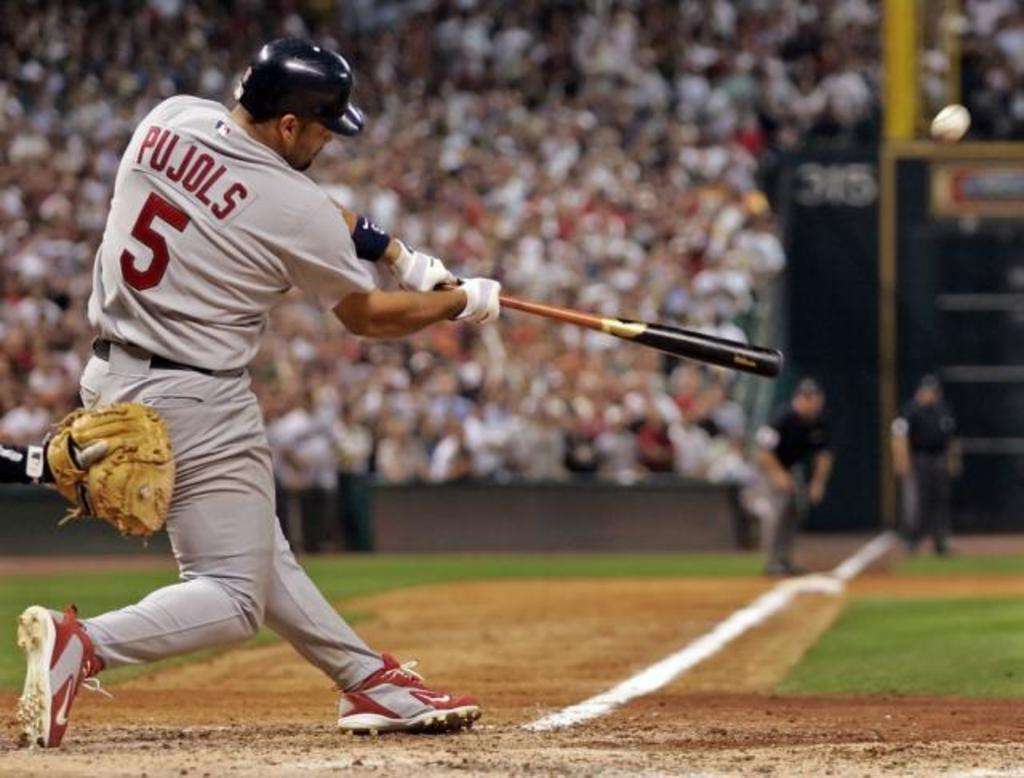<image>
Give a short and clear explanation of the subsequent image. Player number 5 who is at bat swings his bat at a baseball. 